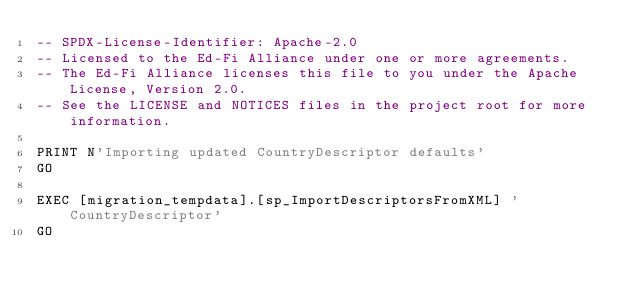Convert code to text. <code><loc_0><loc_0><loc_500><loc_500><_SQL_>-- SPDX-License-Identifier: Apache-2.0
-- Licensed to the Ed-Fi Alliance under one or more agreements.
-- The Ed-Fi Alliance licenses this file to you under the Apache License, Version 2.0.
-- See the LICENSE and NOTICES files in the project root for more information.

PRINT N'Importing updated CountryDescriptor defaults'
GO

EXEC [migration_tempdata].[sp_ImportDescriptorsFromXML] 'CountryDescriptor'
GO</code> 